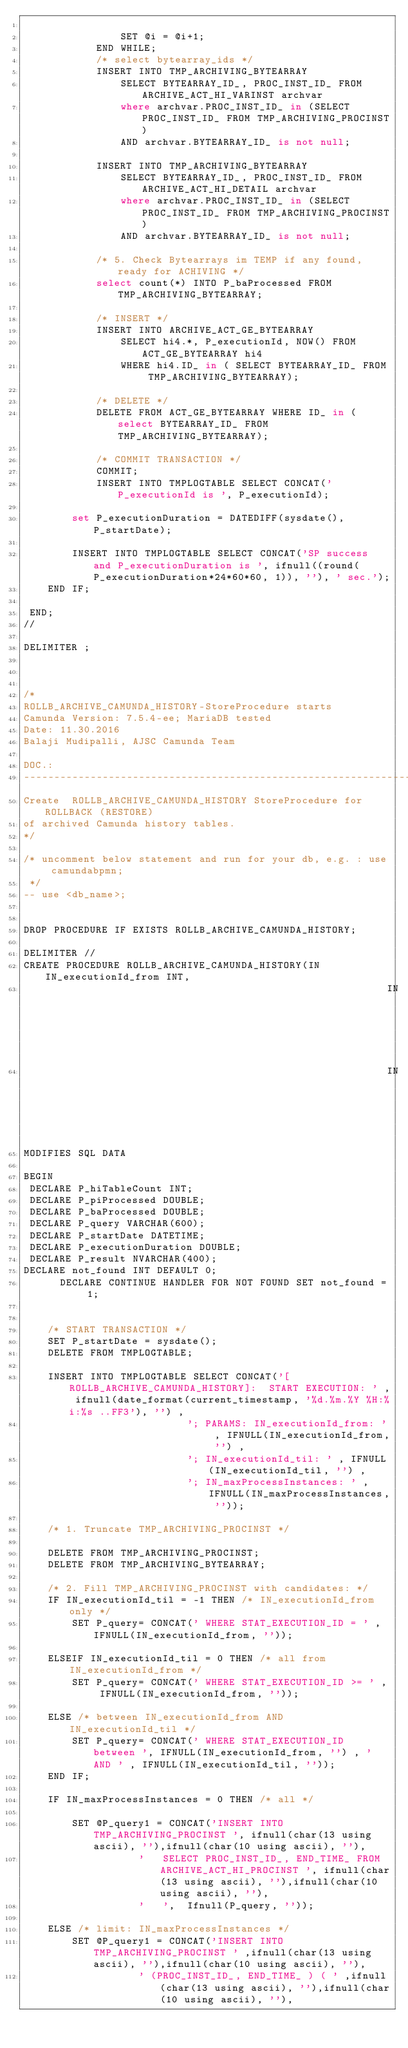<code> <loc_0><loc_0><loc_500><loc_500><_SQL_>					
        		SET @i = @i+1;
        	END WHILE;		
			/* select bytearray_ids */
			INSERT INTO TMP_ARCHIVING_BYTEARRAY
				SELECT BYTEARRAY_ID_, PROC_INST_ID_ FROM ARCHIVE_ACT_HI_VARINST archvar
				where archvar.PROC_INST_ID_ in (SELECT PROC_INST_ID_ FROM TMP_ARCHIVING_PROCINST)
				AND archvar.BYTEARRAY_ID_ is not null;
			
			INSERT INTO TMP_ARCHIVING_BYTEARRAY
				SELECT BYTEARRAY_ID_, PROC_INST_ID_ FROM ARCHIVE_ACT_HI_DETAIL archvar
				where archvar.PROC_INST_ID_ in (SELECT PROC_INST_ID_ FROM TMP_ARCHIVING_PROCINST)
				AND archvar.BYTEARRAY_ID_ is not null;  
        
			/* 5. Check Bytearrays im TEMP if any found, ready for ACHIVING */
			select count(*) INTO P_baProcessed FROM TMP_ARCHIVING_BYTEARRAY;
			
			/* INSERT */
			INSERT INTO ARCHIVE_ACT_GE_BYTEARRAY  
				SELECT hi4.*, P_executionId, NOW() FROM ACT_GE_BYTEARRAY hi4 
				WHERE hi4.ID_ in ( SELECT BYTEARRAY_ID_ FROM TMP_ARCHIVING_BYTEARRAY);
			
			/* DELETE */
			DELETE FROM ACT_GE_BYTEARRAY WHERE ID_ in (select BYTEARRAY_ID_ FROM TMP_ARCHIVING_BYTEARRAY);
			
			/* COMMIT TRANSACTION */
			COMMIT;
			INSERT INTO TMPLOGTABLE SELECT CONCAT('P_executionId is ', P_executionId);	
			
		set P_executionDuration = DATEDIFF(sysdate(), P_startDate);
		
		INSERT INTO TMPLOGTABLE SELECT CONCAT('SP success and P_executionDuration is ', ifnull((round(P_executionDuration*24*60*60, 1)), ''), ' sec.');
    END IF;
   
 END;
//

DELIMITER ;



/* 
ROLLB_ARCHIVE_CAMUNDA_HISTORY-StoreProcedure starts
Camunda Version: 7.5.4-ee; MariaDB tested
Date: 11.30.2016 
Balaji Mudipalli, AJSC Camunda Team

DOC.:
--------------------------------------------------------------------------------------
Create  ROLLB_ARCHIVE_CAMUNDA_HISTORY StoreProcedure for ROLLBACK (RESTORE)
of archived Camunda history tables.
*/

/* uncomment below statement and run for your db, e.g. : use camundabpmn;
 */
-- use <db_name>;


DROP PROCEDURE IF EXISTS ROLLB_ARCHIVE_CAMUNDA_HISTORY;

DELIMITER //
CREATE PROCEDURE ROLLB_ARCHIVE_CAMUNDA_HISTORY(IN IN_executionId_from INT, 
                                                            IN IN_executionId_til INT,
                                                            IN IN_maxProcessInstances INT)
MODIFIES SQL DATA

BEGIN
 DECLARE P_hiTableCount INT;
 DECLARE P_piProcessed DOUBLE;        
 DECLARE P_baProcessed DOUBLE;        
 DECLARE P_query VARCHAR(600);         
 DECLARE P_startDate DATETIME;             
 DECLARE P_executionDuration DOUBLE;
 DECLARE P_result NVARCHAR(400);
DECLARE not_found INT DEFAULT 0;       
      DECLARE CONTINUE HANDLER FOR NOT FOUND SET not_found = 1;
 
                      
    /* START TRANSACTION */
    SET P_startDate = sysdate();
	DELETE FROM TMPLOGTABLE;  
    
	INSERT INTO TMPLOGTABLE SELECT CONCAT('[ROLLB_ARCHIVE_CAMUNDA_HISTORY]:  START EXECUTION: ' , ifnull(date_format(current_timestamp, '%d.%m.%Y %H:%i:%s ..FF3'), '') ,
                           '; PARAMS: IN_executionId_from: ' , IFNULL(IN_executionId_from, '') , 
                           '; IN_executionId_til: ' , IFNULL(IN_executionId_til, '') ,
                           '; IN_maxProcessInstances: ' , IFNULL(IN_maxProcessInstances, ''));
                                                            
    /* 1. Truncate TMP_ARCHIVING_PROCINST */
    
    DELETE FROM TMP_ARCHIVING_PROCINST;
    DELETE FROM TMP_ARCHIVING_BYTEARRAY;
    
    /* 2. Fill TMP_ARCHIVING_PROCINST with candidates: */
    IF IN_executionId_til = -1 THEN /* IN_executionId_from only */
        SET P_query= CONCAT(' WHERE STAT_EXECUTION_ID = ' , IFNULL(IN_executionId_from, ''));
    
    ELSEIF IN_executionId_til = 0 THEN /* all from IN_executionId_from */
        SET P_query= CONCAT(' WHERE STAT_EXECUTION_ID >= ' , IFNULL(IN_executionId_from, ''));
    
    ELSE /* between IN_executionId_from AND IN_executionId_til */
        SET P_query= CONCAT(' WHERE STAT_EXECUTION_ID between ', IFNULL(IN_executionId_from, '') , ' AND ' , IFNULL(IN_executionId_til, ''));
    END IF;
    
    IF IN_maxProcessInstances = 0 THEN /* all */
    
        SET @P_query1 = CONCAT('INSERT INTO TMP_ARCHIVING_PROCINST ', ifnull(char(13 using ascii), ''),ifnull(char(10 using ascii), ''),
                   '   SELECT PROC_INST_ID_, END_TIME_ FROM ARCHIVE_ACT_HI_PROCINST ', ifnull(char(13 using ascii), ''),ifnull(char(10 using ascii), ''),
                   '   ',  Ifnull(P_query, ''));
                   
    ELSE /* limit: IN_maxProcessInstances */
        SET @P_query1 = CONCAT('INSERT INTO TMP_ARCHIVING_PROCINST ' ,ifnull(char(13 using ascii), ''),ifnull(char(10 using ascii), ''),
                   ' (PROC_INST_ID_, END_TIME_ ) ( ' ,ifnull(char(13 using ascii), ''),ifnull(char(10 using ascii), ''),</code> 